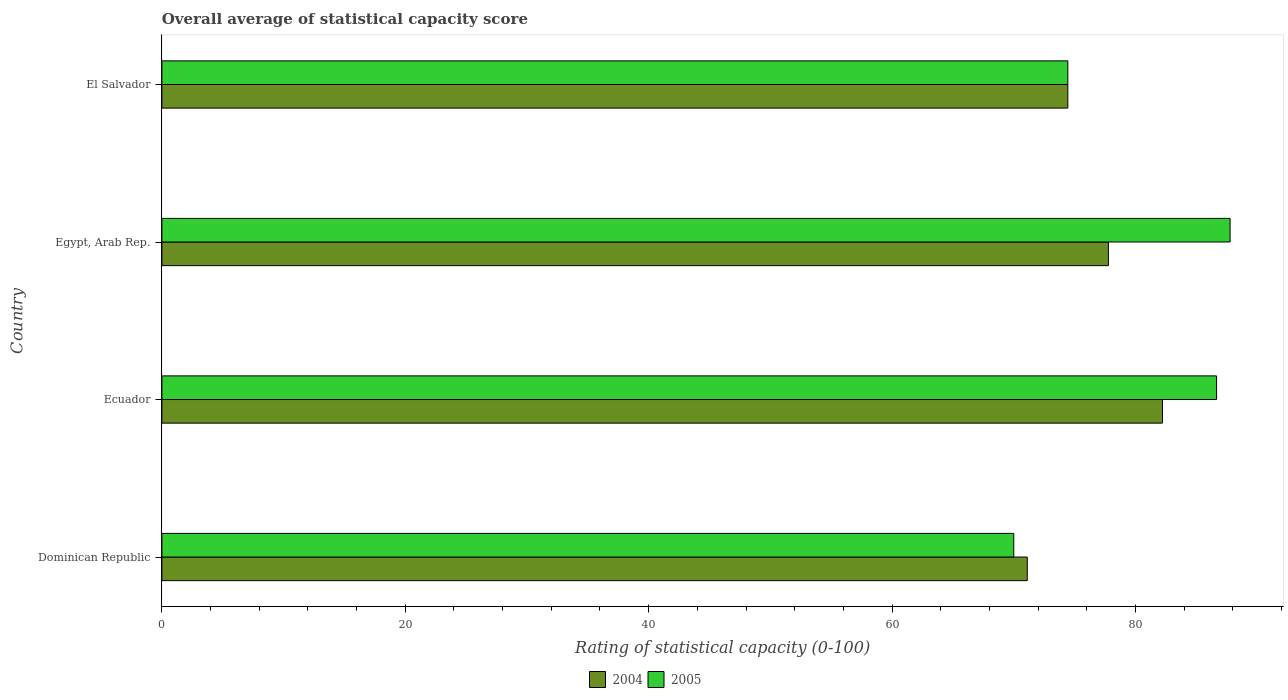Are the number of bars on each tick of the Y-axis equal?
Your response must be concise. Yes. What is the label of the 2nd group of bars from the top?
Provide a short and direct response. Egypt, Arab Rep. In how many cases, is the number of bars for a given country not equal to the number of legend labels?
Ensure brevity in your answer.  0. What is the rating of statistical capacity in 2004 in Dominican Republic?
Offer a very short reply. 71.11. Across all countries, what is the maximum rating of statistical capacity in 2004?
Your answer should be very brief. 82.22. Across all countries, what is the minimum rating of statistical capacity in 2005?
Ensure brevity in your answer.  70. In which country was the rating of statistical capacity in 2005 maximum?
Keep it short and to the point. Egypt, Arab Rep. In which country was the rating of statistical capacity in 2004 minimum?
Offer a terse response. Dominican Republic. What is the total rating of statistical capacity in 2005 in the graph?
Provide a succinct answer. 318.89. What is the difference between the rating of statistical capacity in 2005 in Dominican Republic and that in Egypt, Arab Rep.?
Ensure brevity in your answer.  -17.78. What is the difference between the rating of statistical capacity in 2004 in El Salvador and the rating of statistical capacity in 2005 in Ecuador?
Make the answer very short. -12.22. What is the average rating of statistical capacity in 2005 per country?
Make the answer very short. 79.72. What is the difference between the rating of statistical capacity in 2004 and rating of statistical capacity in 2005 in Egypt, Arab Rep.?
Give a very brief answer. -10. In how many countries, is the rating of statistical capacity in 2005 greater than 40 ?
Keep it short and to the point. 4. What is the ratio of the rating of statistical capacity in 2005 in Ecuador to that in Egypt, Arab Rep.?
Provide a succinct answer. 0.99. What is the difference between the highest and the second highest rating of statistical capacity in 2004?
Provide a short and direct response. 4.44. What is the difference between the highest and the lowest rating of statistical capacity in 2005?
Make the answer very short. 17.78. What does the 1st bar from the top in Egypt, Arab Rep. represents?
Keep it short and to the point. 2005. How many bars are there?
Your answer should be very brief. 8. Are the values on the major ticks of X-axis written in scientific E-notation?
Keep it short and to the point. No. Where does the legend appear in the graph?
Your answer should be very brief. Bottom center. What is the title of the graph?
Make the answer very short. Overall average of statistical capacity score. Does "2014" appear as one of the legend labels in the graph?
Your answer should be very brief. No. What is the label or title of the X-axis?
Your response must be concise. Rating of statistical capacity (0-100). What is the label or title of the Y-axis?
Ensure brevity in your answer.  Country. What is the Rating of statistical capacity (0-100) in 2004 in Dominican Republic?
Provide a succinct answer. 71.11. What is the Rating of statistical capacity (0-100) in 2005 in Dominican Republic?
Provide a succinct answer. 70. What is the Rating of statistical capacity (0-100) in 2004 in Ecuador?
Ensure brevity in your answer.  82.22. What is the Rating of statistical capacity (0-100) in 2005 in Ecuador?
Make the answer very short. 86.67. What is the Rating of statistical capacity (0-100) in 2004 in Egypt, Arab Rep.?
Your answer should be compact. 77.78. What is the Rating of statistical capacity (0-100) of 2005 in Egypt, Arab Rep.?
Keep it short and to the point. 87.78. What is the Rating of statistical capacity (0-100) of 2004 in El Salvador?
Offer a terse response. 74.44. What is the Rating of statistical capacity (0-100) in 2005 in El Salvador?
Offer a very short reply. 74.44. Across all countries, what is the maximum Rating of statistical capacity (0-100) in 2004?
Your answer should be very brief. 82.22. Across all countries, what is the maximum Rating of statistical capacity (0-100) in 2005?
Your answer should be very brief. 87.78. Across all countries, what is the minimum Rating of statistical capacity (0-100) in 2004?
Your response must be concise. 71.11. What is the total Rating of statistical capacity (0-100) in 2004 in the graph?
Offer a very short reply. 305.56. What is the total Rating of statistical capacity (0-100) of 2005 in the graph?
Your answer should be very brief. 318.89. What is the difference between the Rating of statistical capacity (0-100) in 2004 in Dominican Republic and that in Ecuador?
Your answer should be very brief. -11.11. What is the difference between the Rating of statistical capacity (0-100) of 2005 in Dominican Republic and that in Ecuador?
Offer a terse response. -16.67. What is the difference between the Rating of statistical capacity (0-100) in 2004 in Dominican Republic and that in Egypt, Arab Rep.?
Give a very brief answer. -6.67. What is the difference between the Rating of statistical capacity (0-100) in 2005 in Dominican Republic and that in Egypt, Arab Rep.?
Offer a very short reply. -17.78. What is the difference between the Rating of statistical capacity (0-100) of 2005 in Dominican Republic and that in El Salvador?
Provide a succinct answer. -4.44. What is the difference between the Rating of statistical capacity (0-100) in 2004 in Ecuador and that in Egypt, Arab Rep.?
Offer a terse response. 4.44. What is the difference between the Rating of statistical capacity (0-100) in 2005 in Ecuador and that in Egypt, Arab Rep.?
Your answer should be very brief. -1.11. What is the difference between the Rating of statistical capacity (0-100) of 2004 in Ecuador and that in El Salvador?
Offer a very short reply. 7.78. What is the difference between the Rating of statistical capacity (0-100) in 2005 in Ecuador and that in El Salvador?
Your response must be concise. 12.22. What is the difference between the Rating of statistical capacity (0-100) of 2004 in Egypt, Arab Rep. and that in El Salvador?
Keep it short and to the point. 3.33. What is the difference between the Rating of statistical capacity (0-100) of 2005 in Egypt, Arab Rep. and that in El Salvador?
Ensure brevity in your answer.  13.33. What is the difference between the Rating of statistical capacity (0-100) in 2004 in Dominican Republic and the Rating of statistical capacity (0-100) in 2005 in Ecuador?
Keep it short and to the point. -15.56. What is the difference between the Rating of statistical capacity (0-100) in 2004 in Dominican Republic and the Rating of statistical capacity (0-100) in 2005 in Egypt, Arab Rep.?
Your answer should be very brief. -16.67. What is the difference between the Rating of statistical capacity (0-100) of 2004 in Ecuador and the Rating of statistical capacity (0-100) of 2005 in Egypt, Arab Rep.?
Offer a very short reply. -5.56. What is the difference between the Rating of statistical capacity (0-100) in 2004 in Ecuador and the Rating of statistical capacity (0-100) in 2005 in El Salvador?
Offer a terse response. 7.78. What is the average Rating of statistical capacity (0-100) in 2004 per country?
Ensure brevity in your answer.  76.39. What is the average Rating of statistical capacity (0-100) in 2005 per country?
Offer a very short reply. 79.72. What is the difference between the Rating of statistical capacity (0-100) in 2004 and Rating of statistical capacity (0-100) in 2005 in Dominican Republic?
Give a very brief answer. 1.11. What is the difference between the Rating of statistical capacity (0-100) in 2004 and Rating of statistical capacity (0-100) in 2005 in Ecuador?
Your answer should be compact. -4.44. What is the ratio of the Rating of statistical capacity (0-100) in 2004 in Dominican Republic to that in Ecuador?
Your response must be concise. 0.86. What is the ratio of the Rating of statistical capacity (0-100) in 2005 in Dominican Republic to that in Ecuador?
Make the answer very short. 0.81. What is the ratio of the Rating of statistical capacity (0-100) of 2004 in Dominican Republic to that in Egypt, Arab Rep.?
Give a very brief answer. 0.91. What is the ratio of the Rating of statistical capacity (0-100) in 2005 in Dominican Republic to that in Egypt, Arab Rep.?
Provide a succinct answer. 0.8. What is the ratio of the Rating of statistical capacity (0-100) in 2004 in Dominican Republic to that in El Salvador?
Offer a very short reply. 0.96. What is the ratio of the Rating of statistical capacity (0-100) of 2005 in Dominican Republic to that in El Salvador?
Give a very brief answer. 0.94. What is the ratio of the Rating of statistical capacity (0-100) of 2004 in Ecuador to that in Egypt, Arab Rep.?
Offer a terse response. 1.06. What is the ratio of the Rating of statistical capacity (0-100) of 2005 in Ecuador to that in Egypt, Arab Rep.?
Offer a terse response. 0.99. What is the ratio of the Rating of statistical capacity (0-100) of 2004 in Ecuador to that in El Salvador?
Make the answer very short. 1.1. What is the ratio of the Rating of statistical capacity (0-100) of 2005 in Ecuador to that in El Salvador?
Give a very brief answer. 1.16. What is the ratio of the Rating of statistical capacity (0-100) in 2004 in Egypt, Arab Rep. to that in El Salvador?
Offer a very short reply. 1.04. What is the ratio of the Rating of statistical capacity (0-100) of 2005 in Egypt, Arab Rep. to that in El Salvador?
Your response must be concise. 1.18. What is the difference between the highest and the second highest Rating of statistical capacity (0-100) of 2004?
Keep it short and to the point. 4.44. What is the difference between the highest and the second highest Rating of statistical capacity (0-100) of 2005?
Give a very brief answer. 1.11. What is the difference between the highest and the lowest Rating of statistical capacity (0-100) of 2004?
Ensure brevity in your answer.  11.11. What is the difference between the highest and the lowest Rating of statistical capacity (0-100) of 2005?
Ensure brevity in your answer.  17.78. 